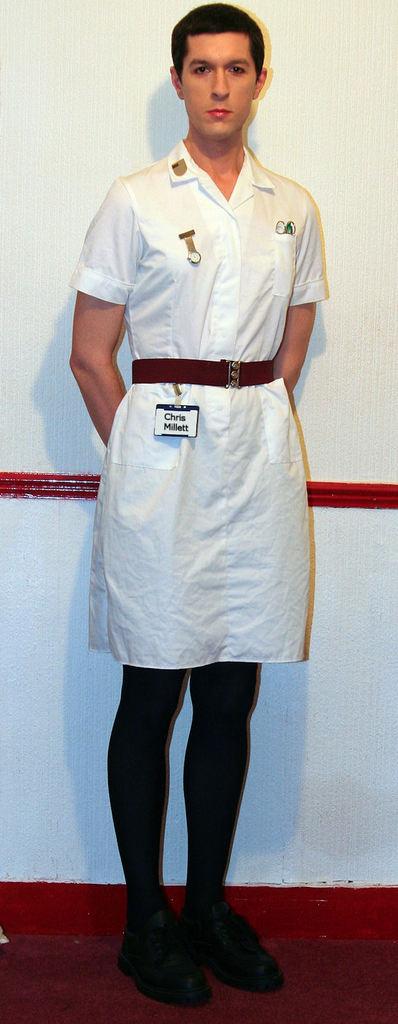What is the man's name?
Offer a very short reply. Chris. 